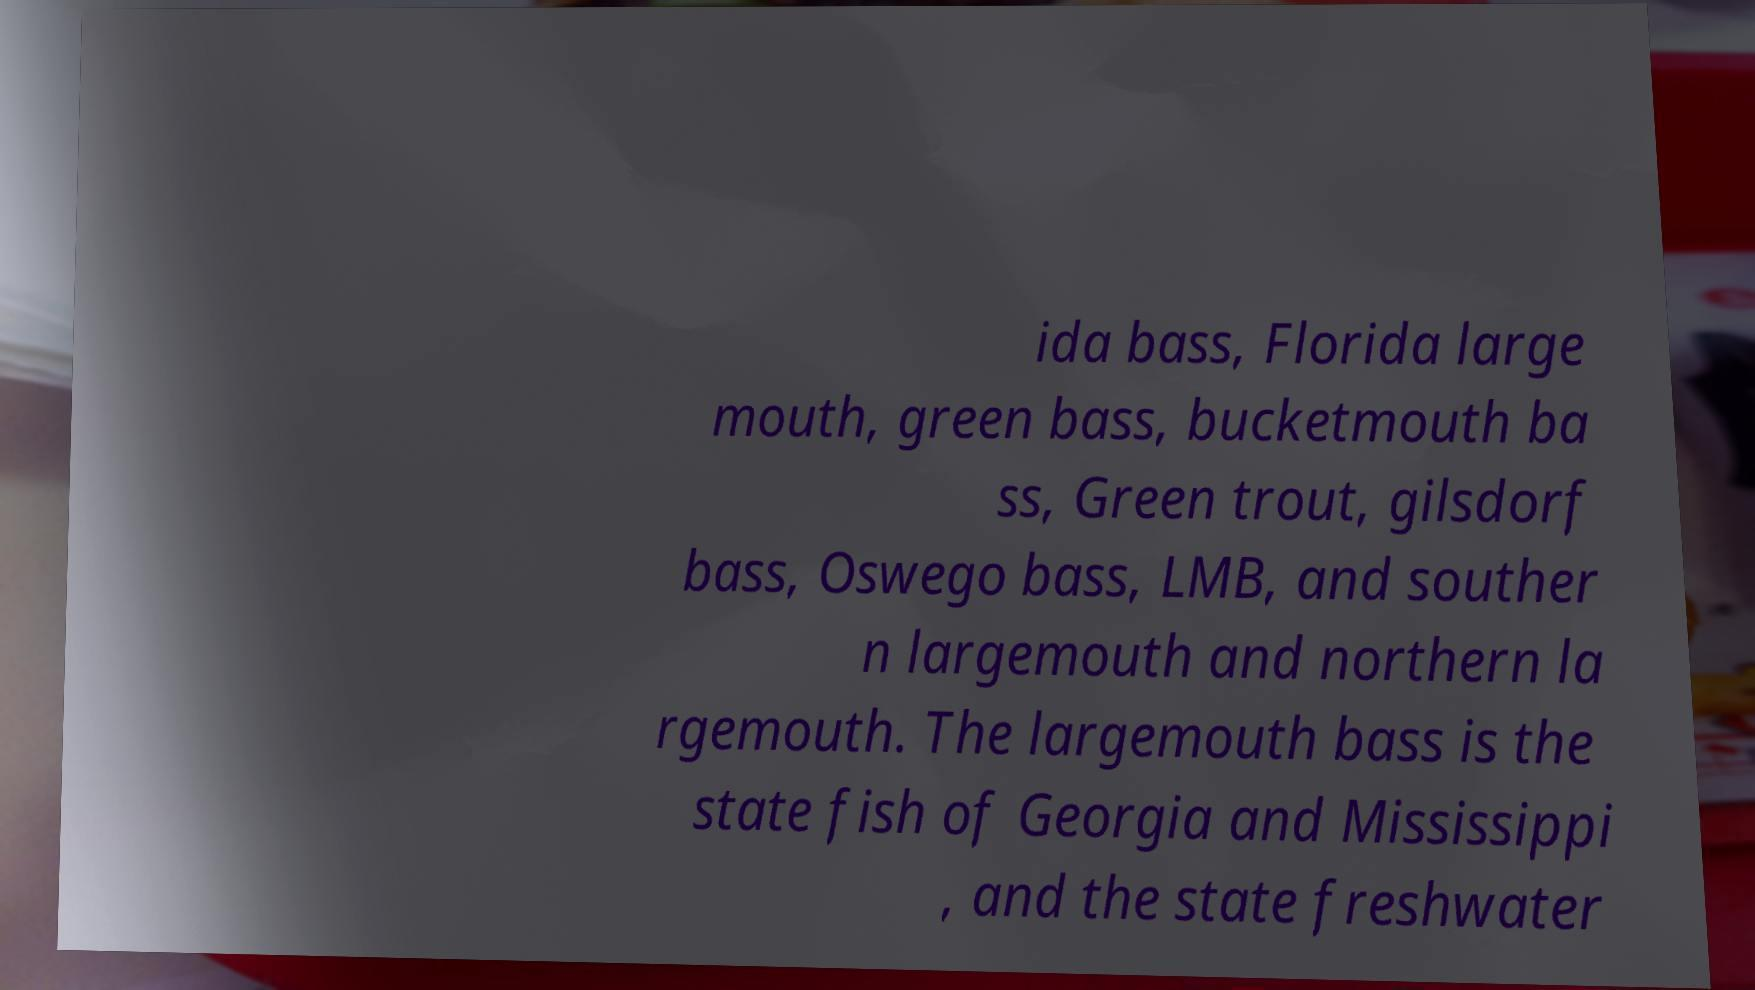I need the written content from this picture converted into text. Can you do that? ida bass, Florida large mouth, green bass, bucketmouth ba ss, Green trout, gilsdorf bass, Oswego bass, LMB, and souther n largemouth and northern la rgemouth. The largemouth bass is the state fish of Georgia and Mississippi , and the state freshwater 